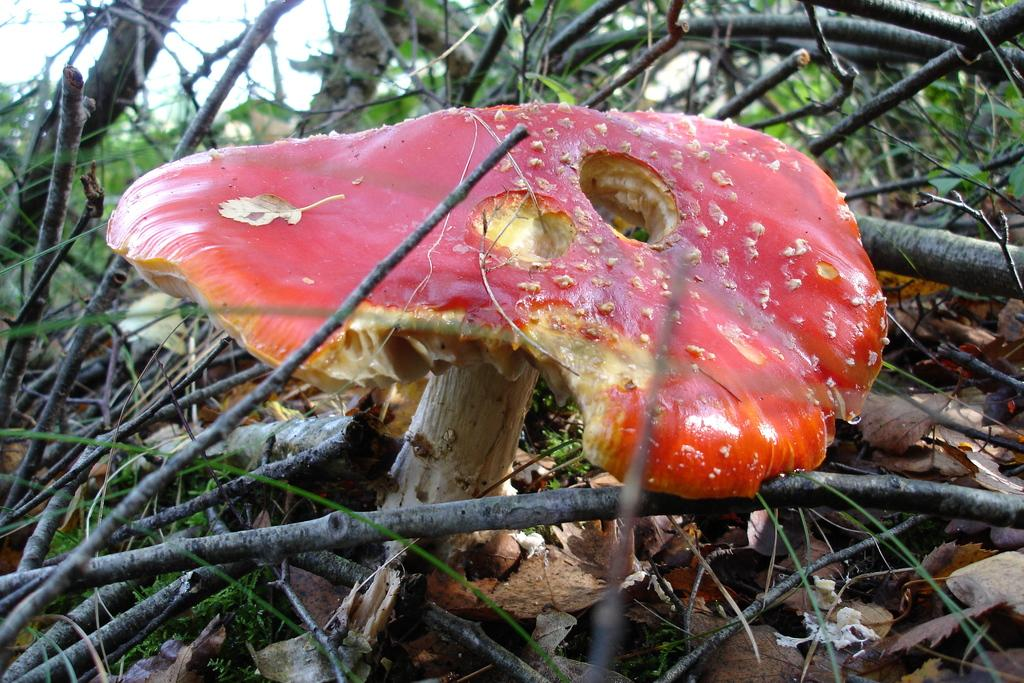What color is the mushroom in the image? The mushroom in the image is red. What can be found at the bottom of the image? Dried leaves and stems are present at the bottom of the image. What type of vegetation is visible in the background of the image? Small plants are visible in the background of the image. What impulse does the spoon have in the image? There is no spoon present in the image, so it cannot have any impulse. 